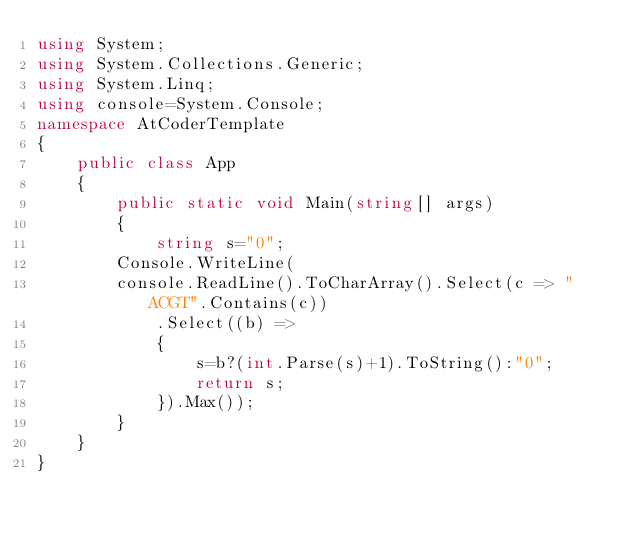Convert code to text. <code><loc_0><loc_0><loc_500><loc_500><_C#_>using System;
using System.Collections.Generic;
using System.Linq;
using console=System.Console;
namespace AtCoderTemplate
{
    public class App
    {
        public static void Main(string[] args)
        {
            string s="0";
        Console.WriteLine(
        console.ReadLine().ToCharArray().Select(c => "ACGT".Contains(c))
            .Select((b) =>
            {
                s=b?(int.Parse(s)+1).ToString():"0";
                return s;
            }).Max());
        }
    }
}</code> 